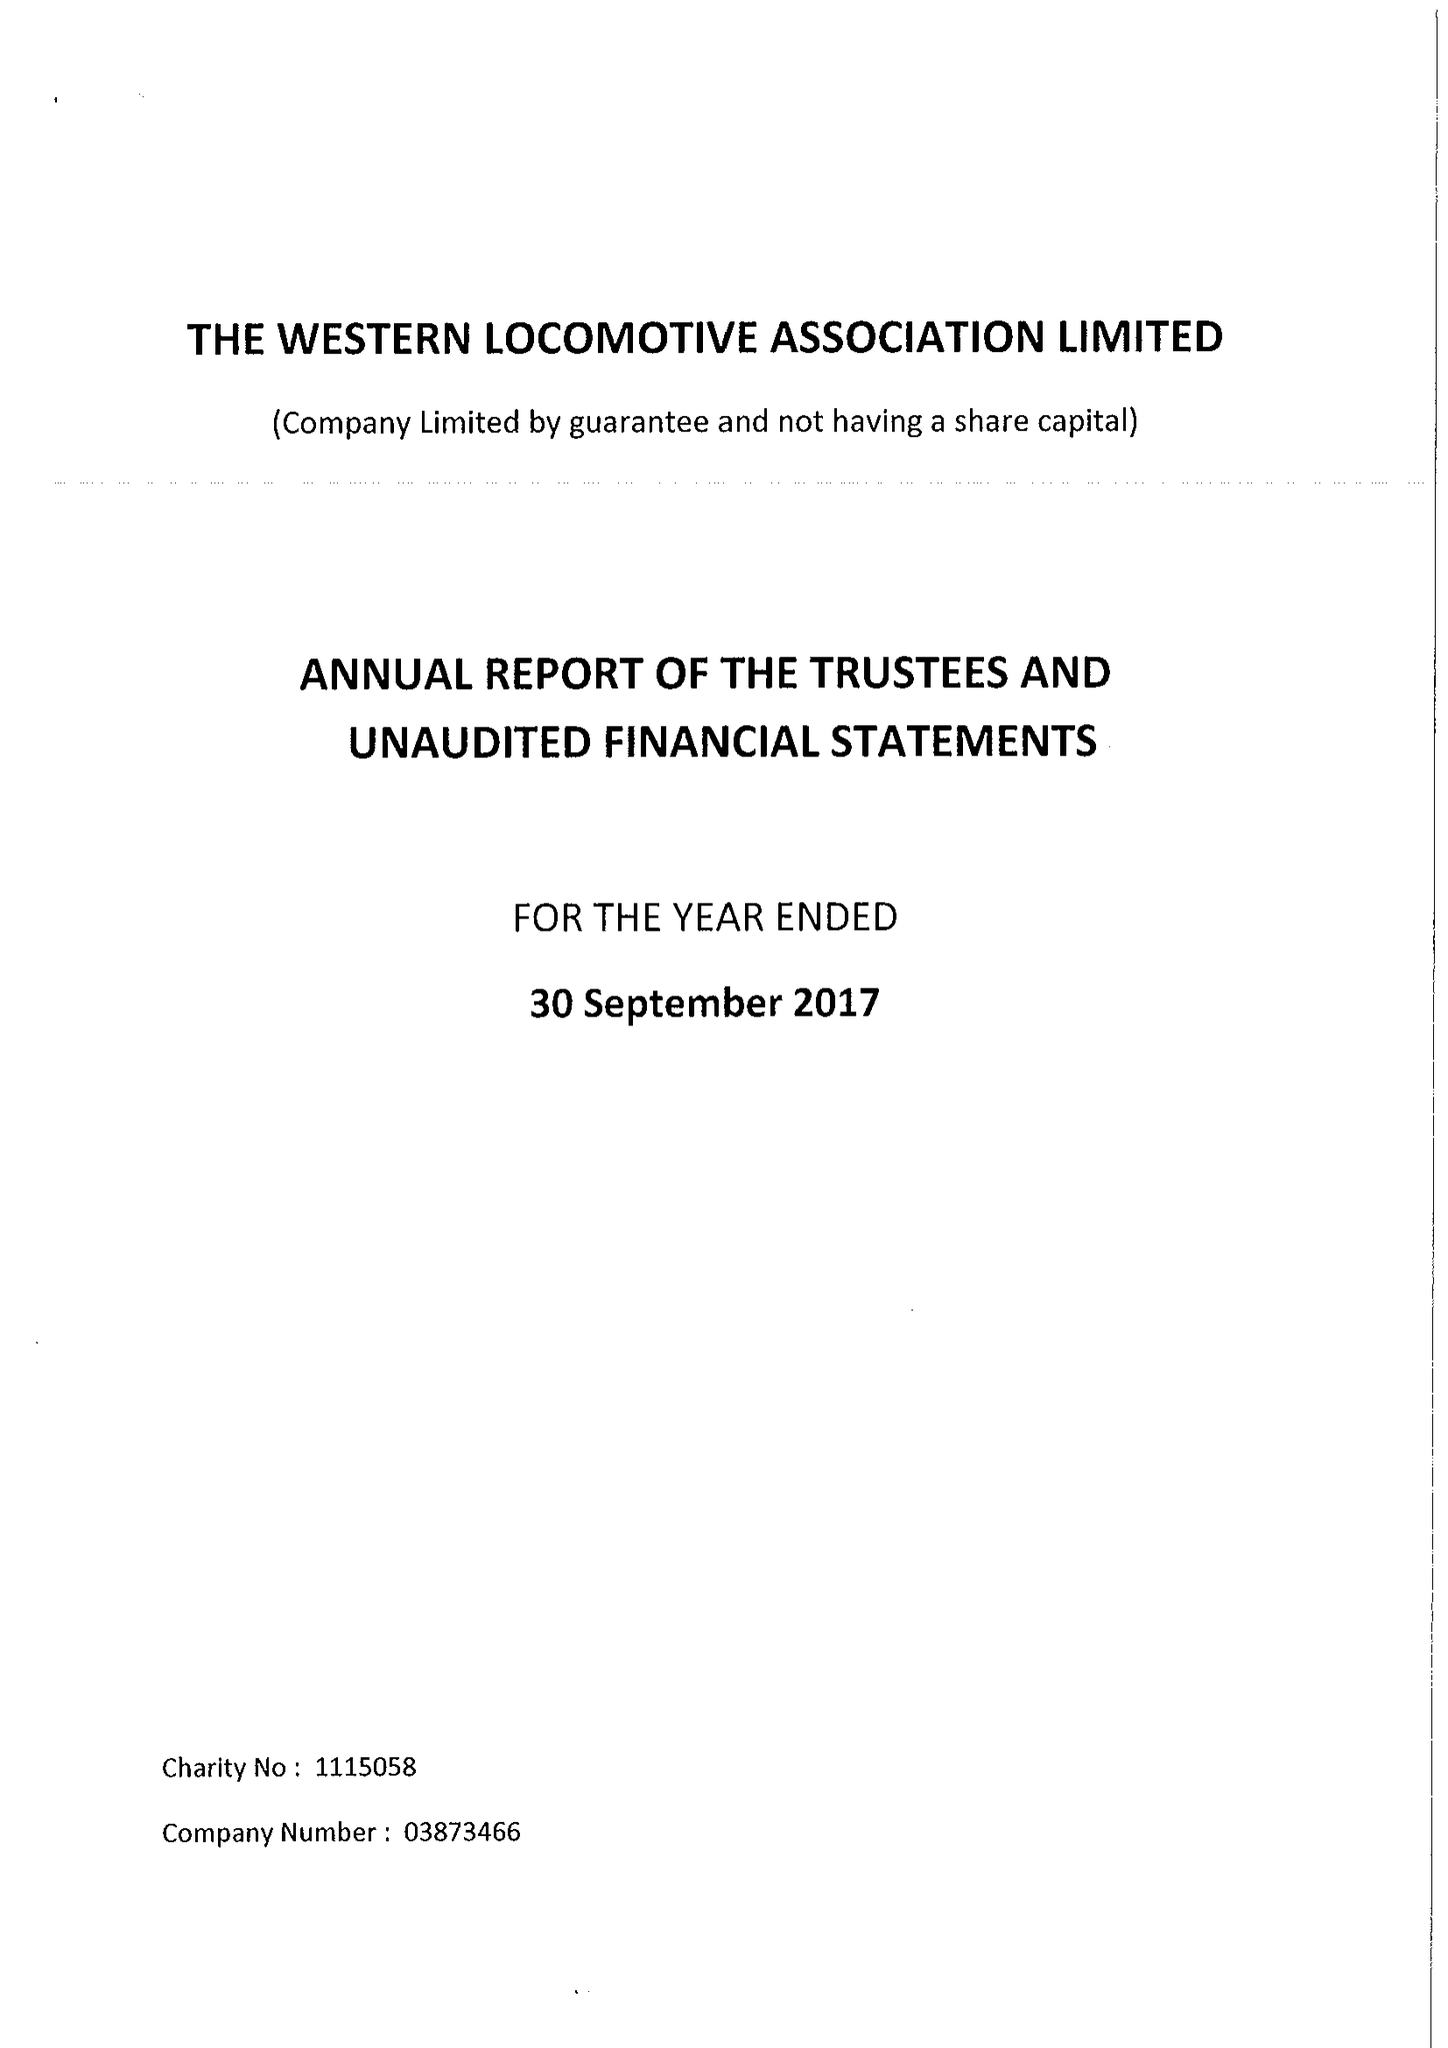What is the value for the address__post_town?
Answer the question using a single word or phrase. STAFFORD 